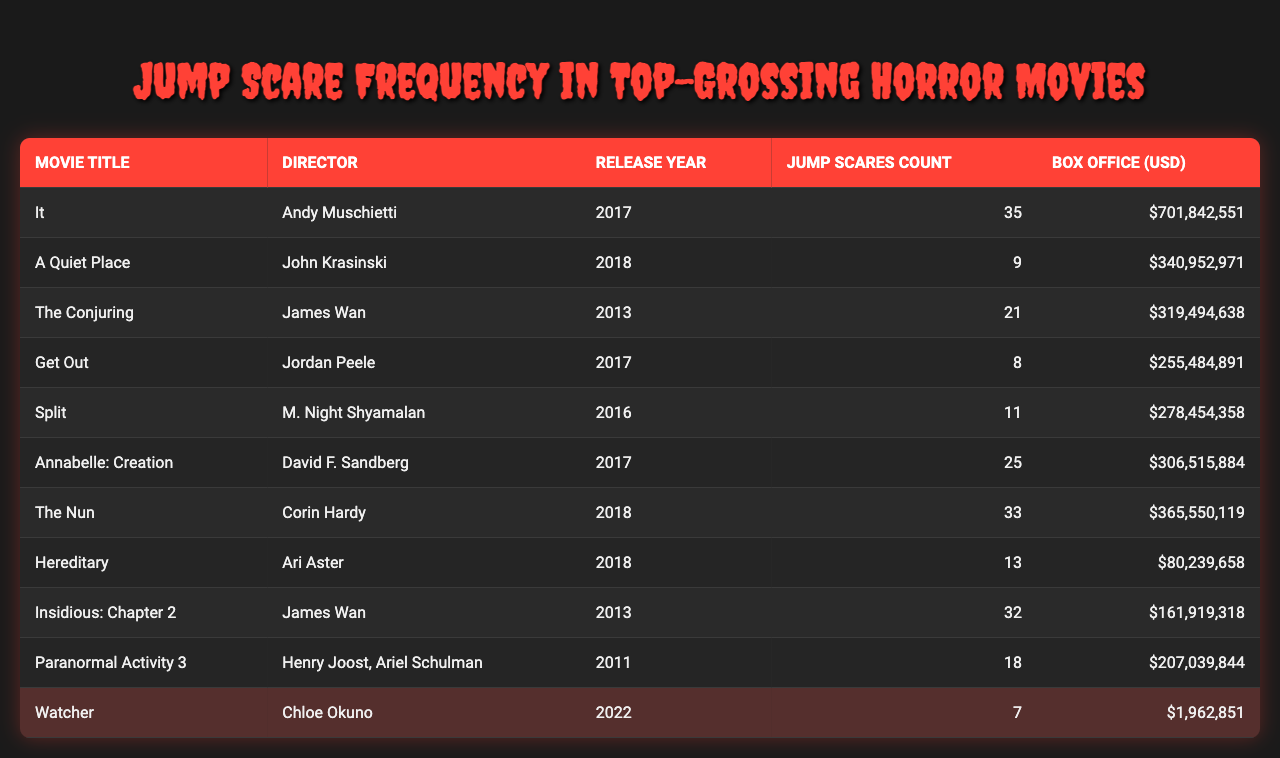What is the movie with the highest jump scare count? Referring to the table, the movie "It" has 35 jump scares, which is the highest count compared to other movies listed.
Answer: It What year was "A Quiet Place" released? The table lists the release year for "A Quiet Place" as 2018, which can be directly found in the corresponding row for the movie.
Answer: 2018 How many jump scares does "Hereditary" have? The table shows that "Hereditary" has 13 jump scares, which can be easily seen in its data entry.
Answer: 13 Which movie has the highest box office revenue? Looking at the box office revenue, "It" has the highest revenue at $701,842,551, more than any other movie listed.
Answer: $701,842,551 Is "Watcher" directed by Chloe Okuno? The table indicates that "Watcher" is indeed directed by Chloe Okuno, as stated in the corresponding row under the Director column.
Answer: Yes What is the total number of jump scares in movies directed by James Wan? Calculating the total: "The Conjuring" has 21 jump scares and "Insidious: Chapter 2" has 32 jump scares. So, 21 + 32 = 53.
Answer: 53 Which movie has the lowest box office earnings? By comparing the box office earnings, "Watcher" has the lowest at $1,962,851, which is clearly listed in the table.
Answer: $1,962,851 What is the average number of jump scares in the movies listed in the table? First, we sum the jump scares: 35 (It) + 9 (A Quiet Place) + 21 (The Conjuring) + 8 (Get Out) + 11 (Split) + 25 (Annabelle: Creation) + 33 (The Nun) + 13 (Hereditary) + 32 (Insidious: Chapter 2) + 18 (Paranormal Activity 3) + 7 (Watcher) =  302. There are 11 movies, so the average is 302 / 11 = 27.5.
Answer: 27.5 How many movies have more than 20 jump scares? By examining the table, the movies with more than 20 jump scares are "It" (35), "Annabelle: Creation" (25), "The Nun" (33), and "Insidious: Chapter 2" (32). That totals up to 4 movies.
Answer: 4 Which two movies have the closest box office earnings? Comparing the box office values, "Get Out" has $255,484,891 and "Split" has $278,454,358. The difference is $22,969,467. The closest are "Get Out" and "Split".
Answer: Get Out and Split 